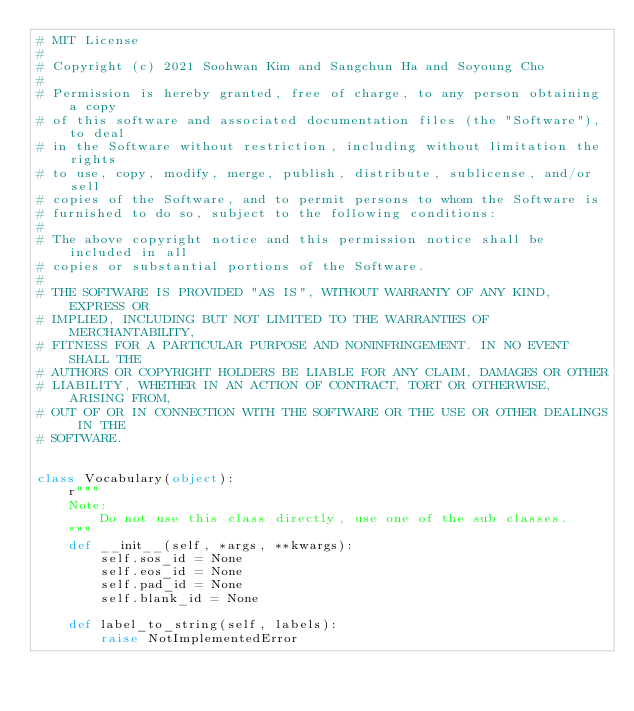Convert code to text. <code><loc_0><loc_0><loc_500><loc_500><_Python_># MIT License
#
# Copyright (c) 2021 Soohwan Kim and Sangchun Ha and Soyoung Cho
#
# Permission is hereby granted, free of charge, to any person obtaining a copy
# of this software and associated documentation files (the "Software"), to deal
# in the Software without restriction, including without limitation the rights
# to use, copy, modify, merge, publish, distribute, sublicense, and/or sell
# copies of the Software, and to permit persons to whom the Software is
# furnished to do so, subject to the following conditions:
#
# The above copyright notice and this permission notice shall be included in all
# copies or substantial portions of the Software.
#
# THE SOFTWARE IS PROVIDED "AS IS", WITHOUT WARRANTY OF ANY KIND, EXPRESS OR
# IMPLIED, INCLUDING BUT NOT LIMITED TO THE WARRANTIES OF MERCHANTABILITY,
# FITNESS FOR A PARTICULAR PURPOSE AND NONINFRINGEMENT. IN NO EVENT SHALL THE
# AUTHORS OR COPYRIGHT HOLDERS BE LIABLE FOR ANY CLAIM, DAMAGES OR OTHER
# LIABILITY, WHETHER IN AN ACTION OF CONTRACT, TORT OR OTHERWISE, ARISING FROM,
# OUT OF OR IN CONNECTION WITH THE SOFTWARE OR THE USE OR OTHER DEALINGS IN THE
# SOFTWARE.


class Vocabulary(object):
    r"""
    Note:
        Do not use this class directly, use one of the sub classes.
    """
    def __init__(self, *args, **kwargs):
        self.sos_id = None
        self.eos_id = None
        self.pad_id = None
        self.blank_id = None

    def label_to_string(self, labels):
        raise NotImplementedError
</code> 